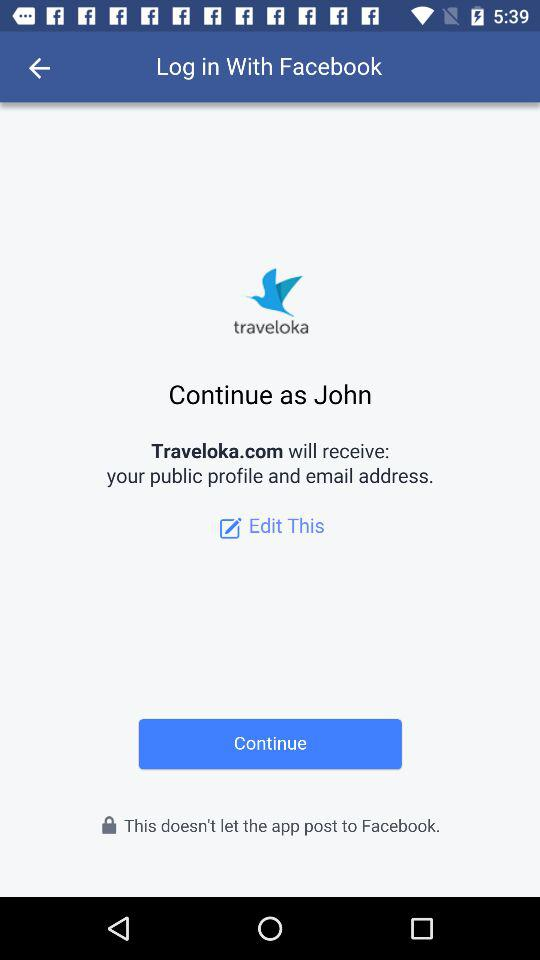What is the user name? The user name is John. 